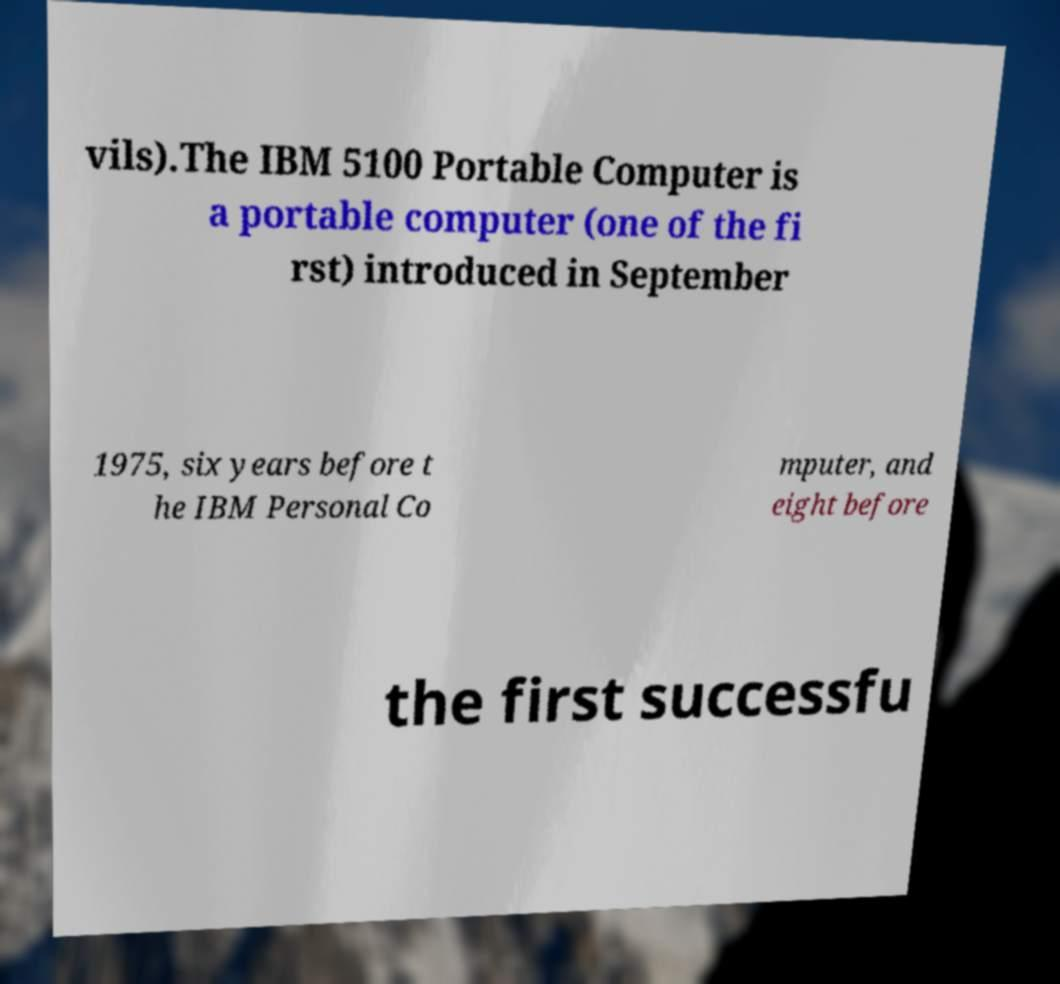For documentation purposes, I need the text within this image transcribed. Could you provide that? vils).The IBM 5100 Portable Computer is a portable computer (one of the fi rst) introduced in September 1975, six years before t he IBM Personal Co mputer, and eight before the first successfu 